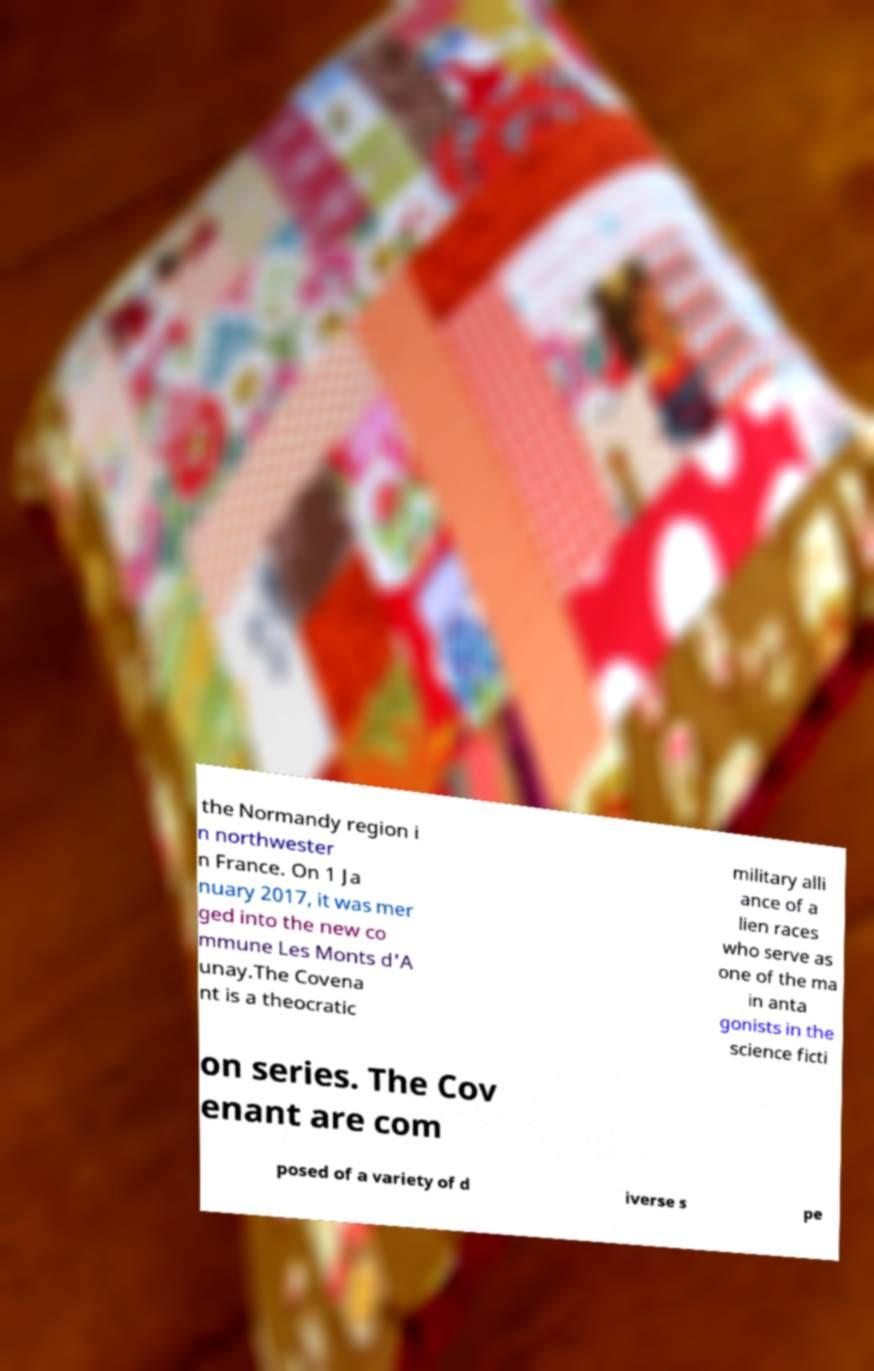Could you extract and type out the text from this image? the Normandy region i n northwester n France. On 1 Ja nuary 2017, it was mer ged into the new co mmune Les Monts d'A unay.The Covena nt is a theocratic military alli ance of a lien races who serve as one of the ma in anta gonists in the science ficti on series. The Cov enant are com posed of a variety of d iverse s pe 